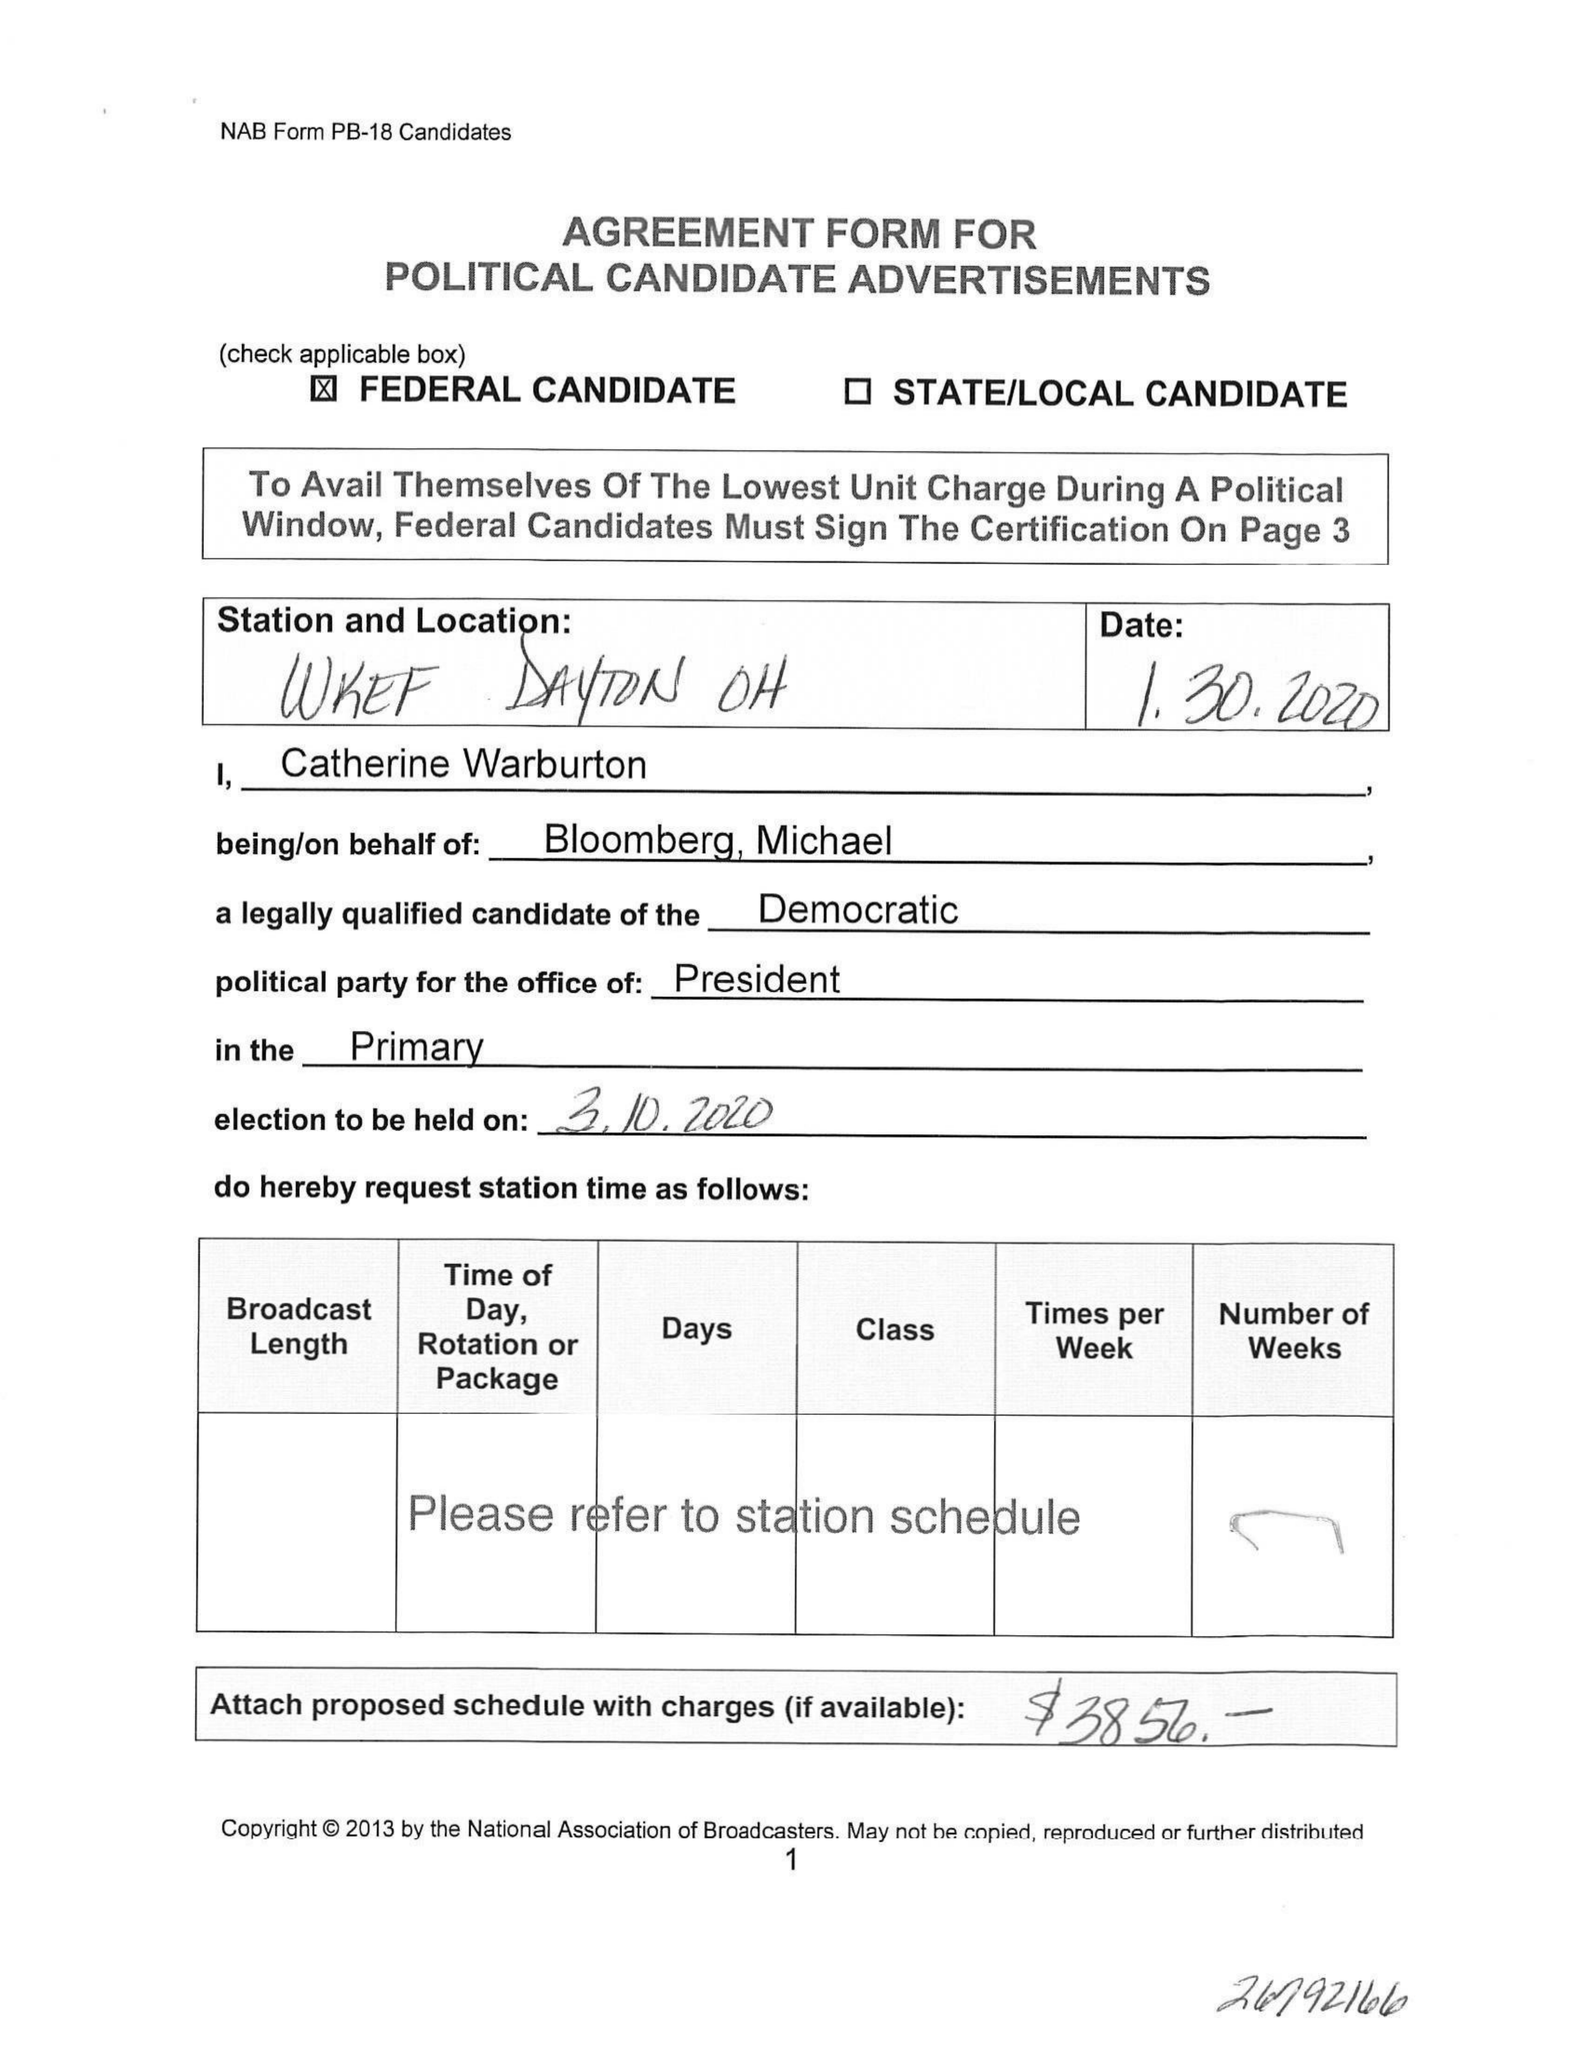What is the value for the contract_num?
Answer the question using a single word or phrase. None 